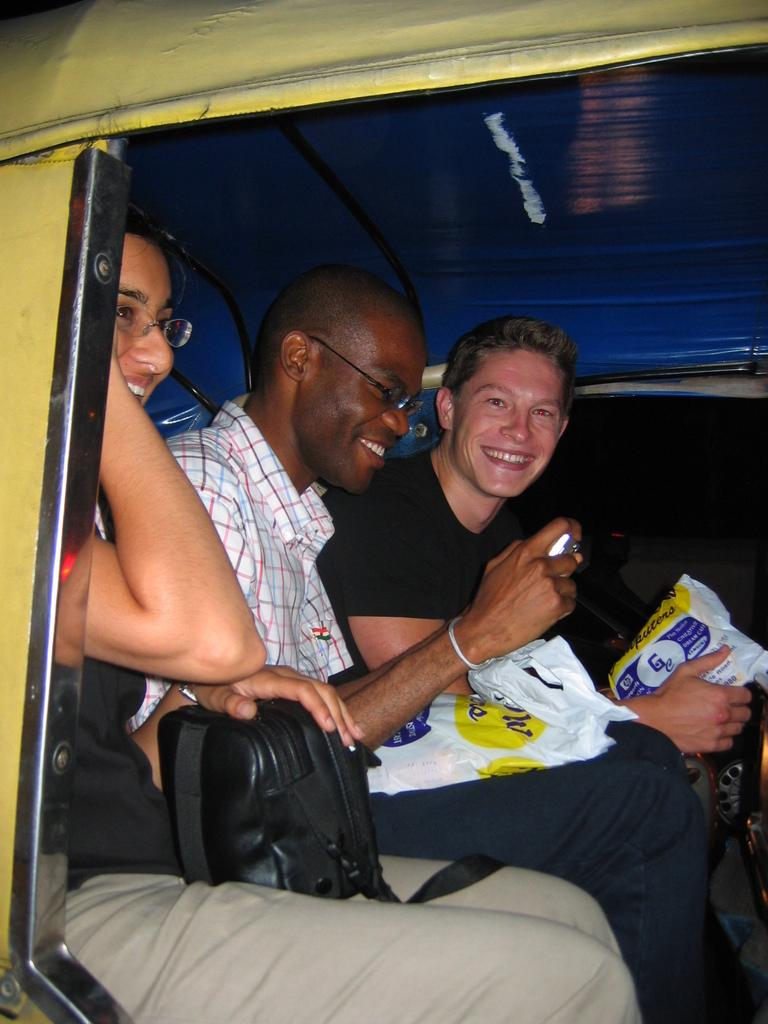How many people are in the image? There are three persons in the image. What are the persons doing in the image? The persons are sitting in a motor vehicle. What are the persons holding in the image? The persons are holding polythene bags. What type of thrill can be seen on the faces of the persons in the image? There is no indication of any specific emotion or thrill on the faces of the persons in the image. --- Facts: 1. There is a person standing on a bridge. 2. The person is holding a fishing rod. 3. The bridge is over a river. 4. There are trees in the background. Absurd Topics: parrot, bicycle, sand Conversation: What is the person in the image doing? The person is standing on a bridge and holding a fishing rod. Where is the person located in the image? The person is standing on a bridge. What is the bridge situated over in the image? The bridge is over a river. What can be seen in the background of the image? There are trees in the background. Reasoning: Let's think step by step in order to produce the conversation. We start by identifying the main subject in the image, which is the person standing on the bridge. Then, we describe their actions and the object they are holding, which is a fishing rod. Next, we mention the location of the bridge, which is over a river. Finally, we expand the conversation to include the background, noting that there are trees present. Absurd Question/Answer: Can you see a parrot sitting on the person's shoulder in the image? No, there is no parrot present in the image. Is the person riding a bicycle in the image? No, the person is standing on a bridge, not riding a bicycle. 